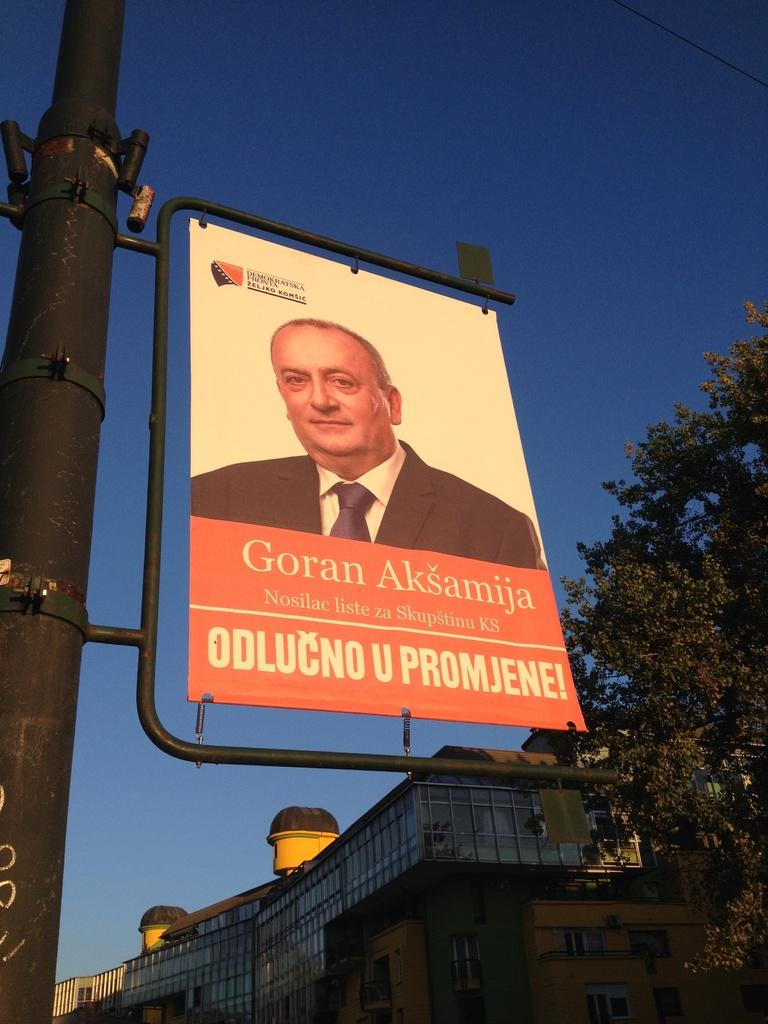<image>
Describe the image concisely. Sign for Goran Aksamija hanging outdoors on a pole. 